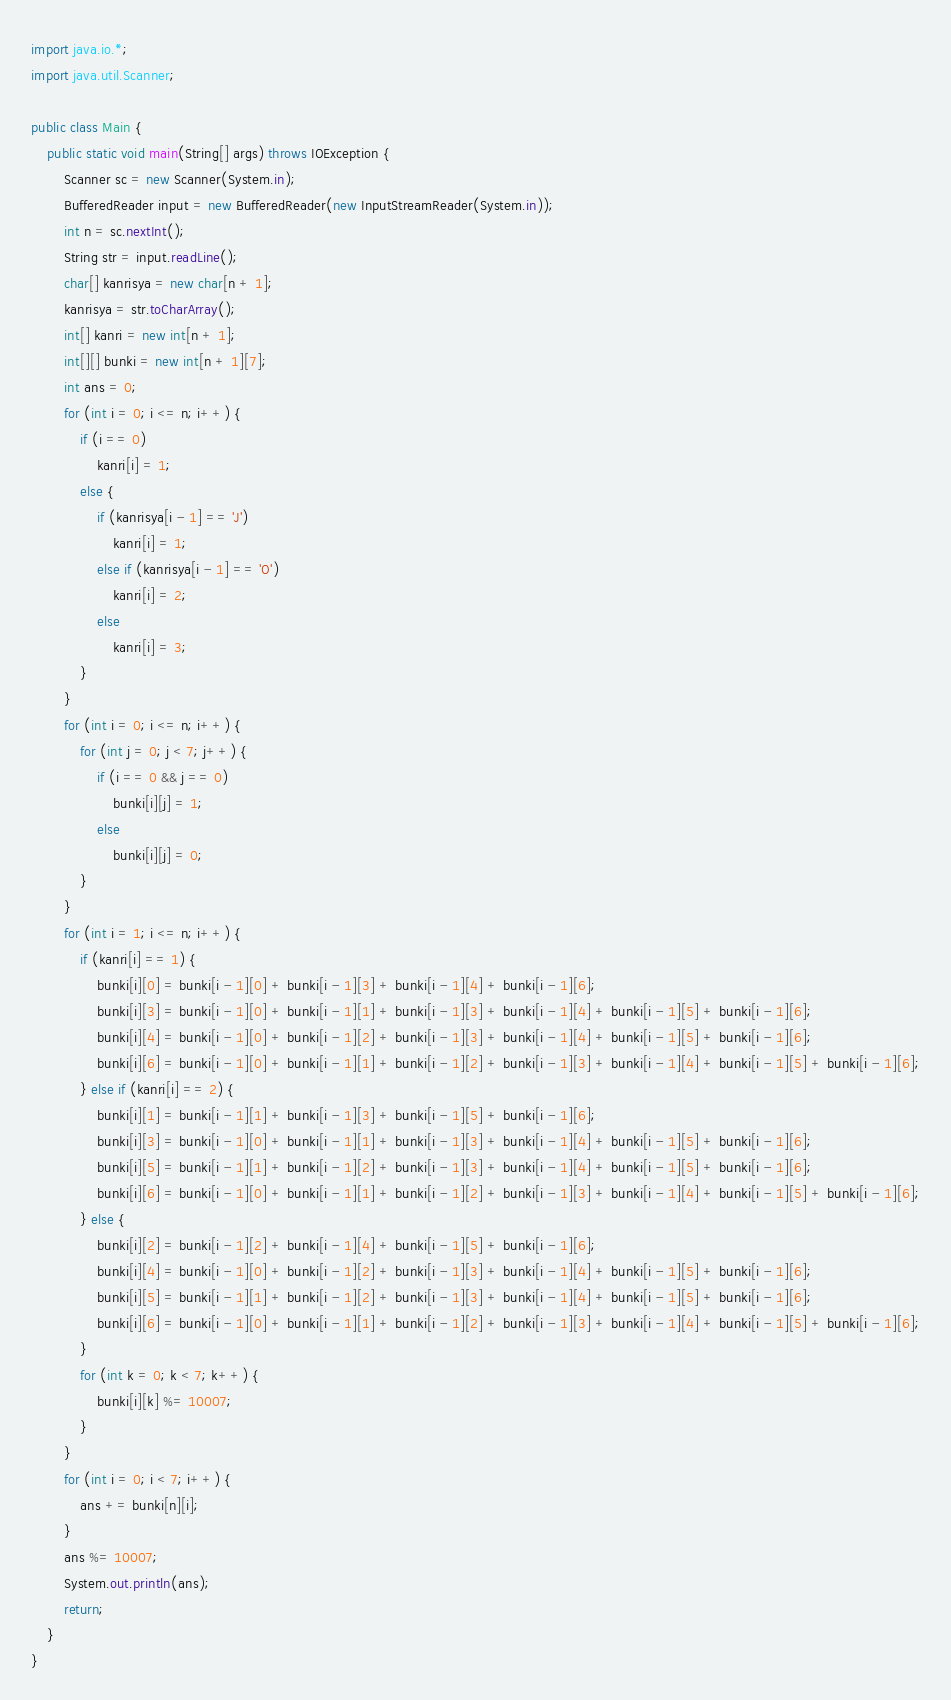Convert code to text. <code><loc_0><loc_0><loc_500><loc_500><_Java_>import java.io.*;
import java.util.Scanner;

public class Main {
	public static void main(String[] args) throws IOException {
		Scanner sc = new Scanner(System.in);
		BufferedReader input = new BufferedReader(new InputStreamReader(System.in));
		int n = sc.nextInt();
		String str = input.readLine();
		char[] kanrisya = new char[n + 1];
		kanrisya = str.toCharArray();
		int[] kanri = new int[n + 1];
		int[][] bunki = new int[n + 1][7];
		int ans = 0;
		for (int i = 0; i <= n; i++) {
			if (i == 0)
				kanri[i] = 1;
			else {
				if (kanrisya[i - 1] == 'J')
					kanri[i] = 1;
				else if (kanrisya[i - 1] == 'O')
					kanri[i] = 2;
				else 
					kanri[i] = 3;
			}
		}
		for (int i = 0; i <= n; i++) {
			for (int j = 0; j < 7; j++) {
				if (i == 0 && j == 0)
					bunki[i][j] = 1;
				else
					bunki[i][j] = 0;
			}
		}
		for (int i = 1; i <= n; i++) {
			if (kanri[i] == 1) {
				bunki[i][0] = bunki[i - 1][0] + bunki[i - 1][3] + bunki[i - 1][4] + bunki[i - 1][6];
				bunki[i][3] = bunki[i - 1][0] + bunki[i - 1][1] + bunki[i - 1][3] + bunki[i - 1][4] + bunki[i - 1][5] + bunki[i - 1][6];
				bunki[i][4] = bunki[i - 1][0] + bunki[i - 1][2] + bunki[i - 1][3] + bunki[i - 1][4] + bunki[i - 1][5] + bunki[i - 1][6];
				bunki[i][6] = bunki[i - 1][0] + bunki[i - 1][1] + bunki[i - 1][2] + bunki[i - 1][3] + bunki[i - 1][4] + bunki[i - 1][5] + bunki[i - 1][6];
			} else if (kanri[i] == 2) {
				bunki[i][1] = bunki[i - 1][1] + bunki[i - 1][3] + bunki[i - 1][5] + bunki[i - 1][6];
				bunki[i][3] = bunki[i - 1][0] + bunki[i - 1][1] + bunki[i - 1][3] + bunki[i - 1][4] + bunki[i - 1][5] + bunki[i - 1][6];
				bunki[i][5] = bunki[i - 1][1] + bunki[i - 1][2] + bunki[i - 1][3] + bunki[i - 1][4] + bunki[i - 1][5] + bunki[i - 1][6];
				bunki[i][6] = bunki[i - 1][0] + bunki[i - 1][1] + bunki[i - 1][2] + bunki[i - 1][3] + bunki[i - 1][4] + bunki[i - 1][5] + bunki[i - 1][6];
			} else {
				bunki[i][2] = bunki[i - 1][2] + bunki[i - 1][4] + bunki[i - 1][5] + bunki[i - 1][6];
				bunki[i][4] = bunki[i - 1][0] + bunki[i - 1][2] + bunki[i - 1][3] + bunki[i - 1][4] + bunki[i - 1][5] + bunki[i - 1][6];
				bunki[i][5] = bunki[i - 1][1] + bunki[i - 1][2] + bunki[i - 1][3] + bunki[i - 1][4] + bunki[i - 1][5] + bunki[i - 1][6];
				bunki[i][6] = bunki[i - 1][0] + bunki[i - 1][1] + bunki[i - 1][2] + bunki[i - 1][3] + bunki[i - 1][4] + bunki[i - 1][5] + bunki[i - 1][6];
			}
			for (int k = 0; k < 7; k++) {
				bunki[i][k] %= 10007;
			}
		}
		for (int i = 0; i < 7; i++) {
			ans += bunki[n][i];
		}
		ans %= 10007;
		System.out.println(ans);
		return;
	}
}</code> 